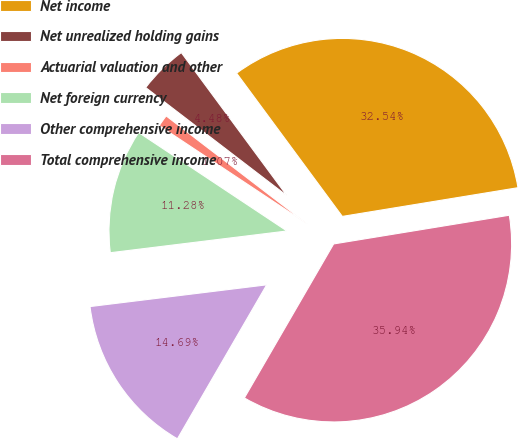Convert chart. <chart><loc_0><loc_0><loc_500><loc_500><pie_chart><fcel>Net income<fcel>Net unrealized holding gains<fcel>Actuarial valuation and other<fcel>Net foreign currency<fcel>Other comprehensive income<fcel>Total comprehensive income<nl><fcel>32.54%<fcel>4.48%<fcel>1.07%<fcel>11.28%<fcel>14.69%<fcel>35.94%<nl></chart> 